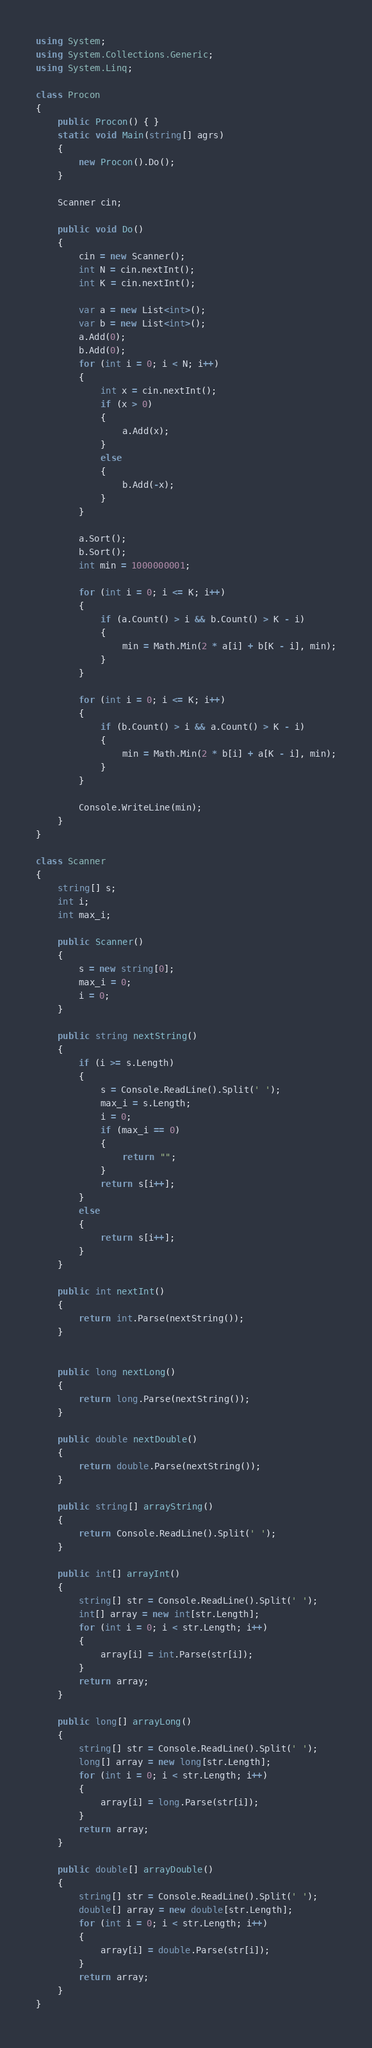<code> <loc_0><loc_0><loc_500><loc_500><_C#_>using System;
using System.Collections.Generic;
using System.Linq;

class Procon
{
    public Procon() { }
    static void Main(string[] agrs)
    {
        new Procon().Do();
    }

    Scanner cin;

    public void Do()
    {
        cin = new Scanner();
        int N = cin.nextInt();
        int K = cin.nextInt();

        var a = new List<int>();
        var b = new List<int>();
        a.Add(0);
        b.Add(0);
        for (int i = 0; i < N; i++)
        {
            int x = cin.nextInt();
            if (x > 0)
            {
                a.Add(x);
            }
            else
            {
                b.Add(-x);
            }
        }

        a.Sort();
        b.Sort();
        int min = 1000000001;

        for (int i = 0; i <= K; i++)
        {
            if (a.Count() > i && b.Count() > K - i)
            {
                min = Math.Min(2 * a[i] + b[K - i], min);
            }
        }

        for (int i = 0; i <= K; i++)
        {
            if (b.Count() > i && a.Count() > K - i)
            {
                min = Math.Min(2 * b[i] + a[K - i], min);
            }
        }

        Console.WriteLine(min);
    }
}

class Scanner
{
    string[] s;
    int i;
    int max_i;

    public Scanner()
    {
        s = new string[0];
        max_i = 0;
        i = 0;
    }

    public string nextString()
    {
        if (i >= s.Length)
        {
            s = Console.ReadLine().Split(' ');
            max_i = s.Length;
            i = 0;
            if (max_i == 0)
            {
                return "";
            }
            return s[i++];
        }
        else
        {
            return s[i++];
        }
    }

    public int nextInt()
    {
        return int.Parse(nextString());
    }


    public long nextLong()
    {
        return long.Parse(nextString());
    }

    public double nextDouble()
    {
        return double.Parse(nextString());
    }

    public string[] arrayString()
    {
        return Console.ReadLine().Split(' ');
    }

    public int[] arrayInt()
    {
        string[] str = Console.ReadLine().Split(' ');
        int[] array = new int[str.Length];
        for (int i = 0; i < str.Length; i++)
        {
            array[i] = int.Parse(str[i]);
        }
        return array;
    }

    public long[] arrayLong()
    {
        string[] str = Console.ReadLine().Split(' ');
        long[] array = new long[str.Length];
        for (int i = 0; i < str.Length; i++)
        {
            array[i] = long.Parse(str[i]);
        }
        return array;
    }

    public double[] arrayDouble()
    {
        string[] str = Console.ReadLine().Split(' ');
        double[] array = new double[str.Length];
        for (int i = 0; i < str.Length; i++)
        {
            array[i] = double.Parse(str[i]);
        }
        return array;
    }
}
</code> 